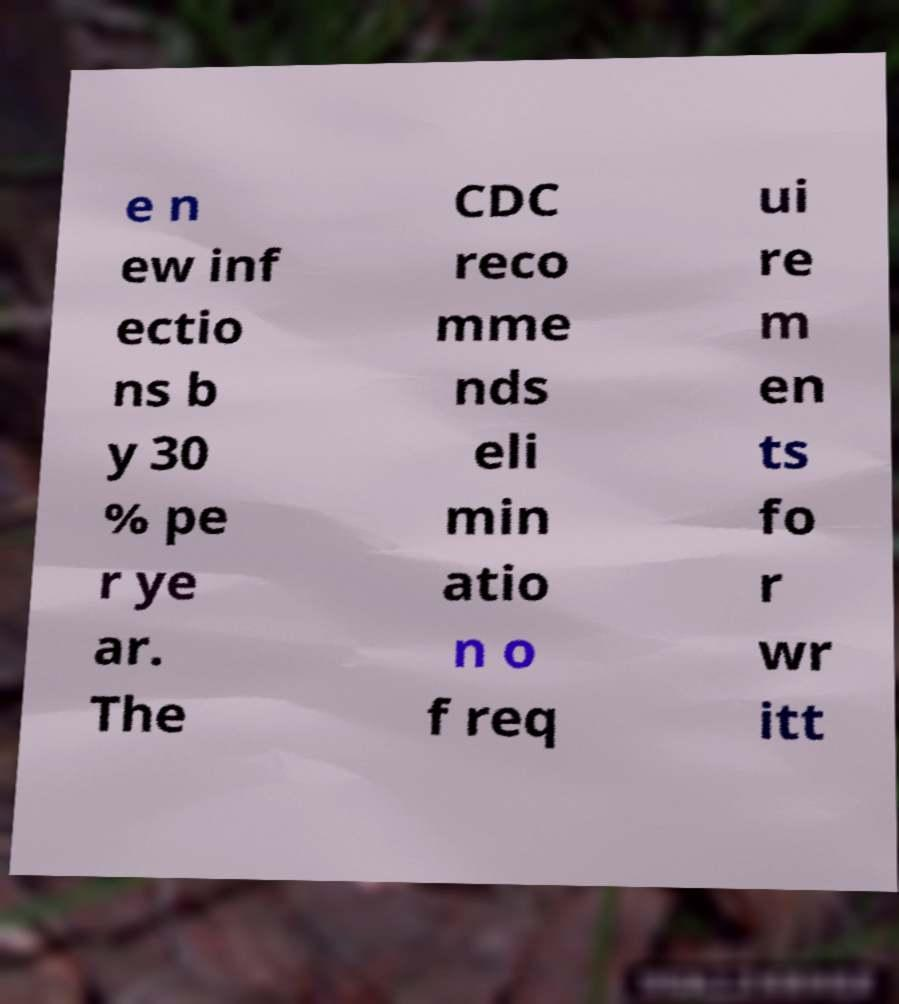Can you read and provide the text displayed in the image?This photo seems to have some interesting text. Can you extract and type it out for me? e n ew inf ectio ns b y 30 % pe r ye ar. The CDC reco mme nds eli min atio n o f req ui re m en ts fo r wr itt 